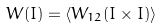Convert formula to latex. <formula><loc_0><loc_0><loc_500><loc_500>W ( I ) = \langle W _ { 1 2 } ( I \times I ) \rangle</formula> 